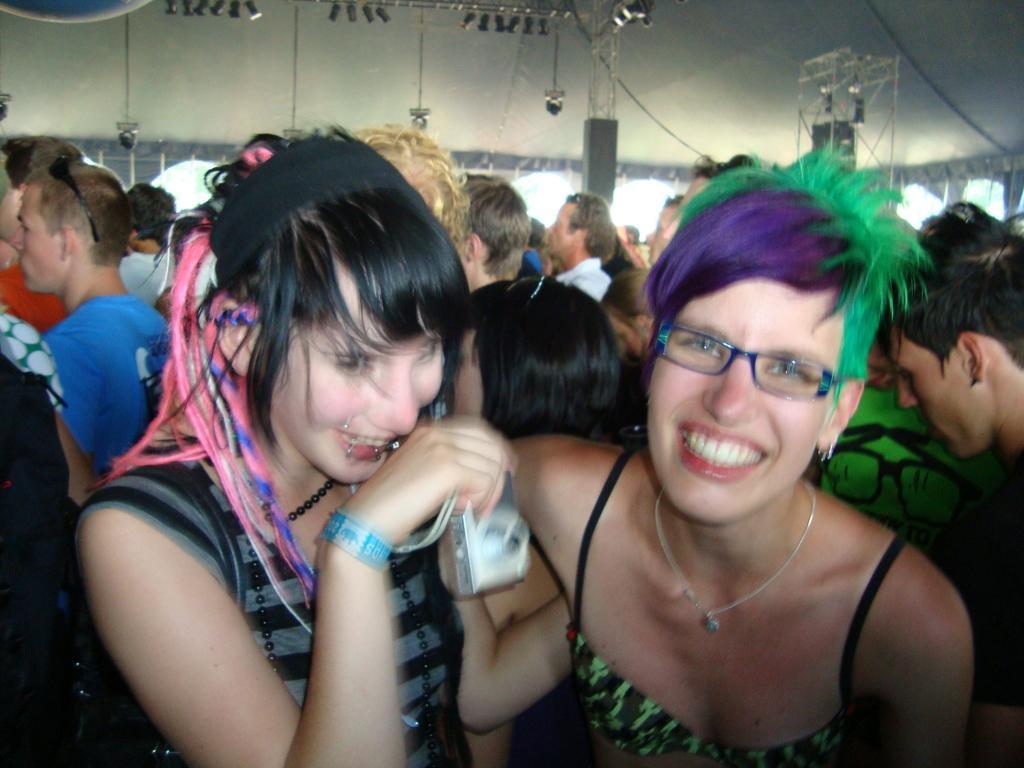Describe this image in one or two sentences. In the image we can see there are people standing and in front there is a woman holding camera in her hand. 